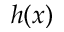<formula> <loc_0><loc_0><loc_500><loc_500>h ( x )</formula> 